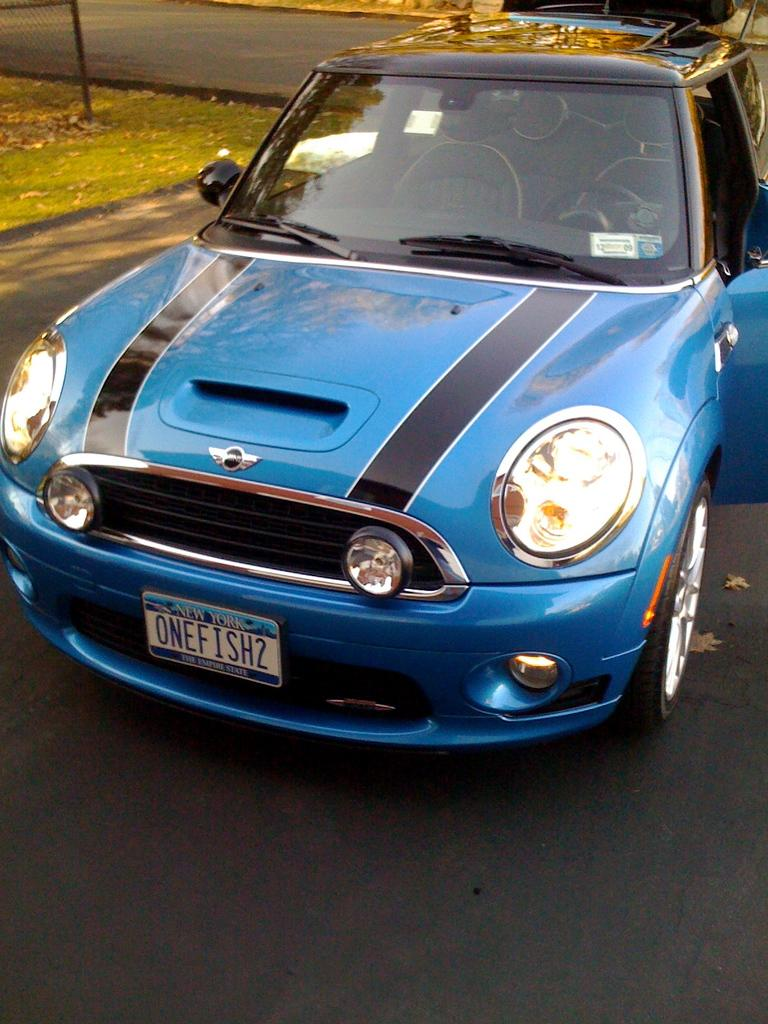What is the main subject of the image? There is a car in the image. Where is the car located? The car is parked on the road. What can be seen behind the car? There is a ground covered with grass behind the car. Is there a beggar standing next to the car in the image? There is no mention of a beggar in the image, so we cannot confirm or deny their presence. 